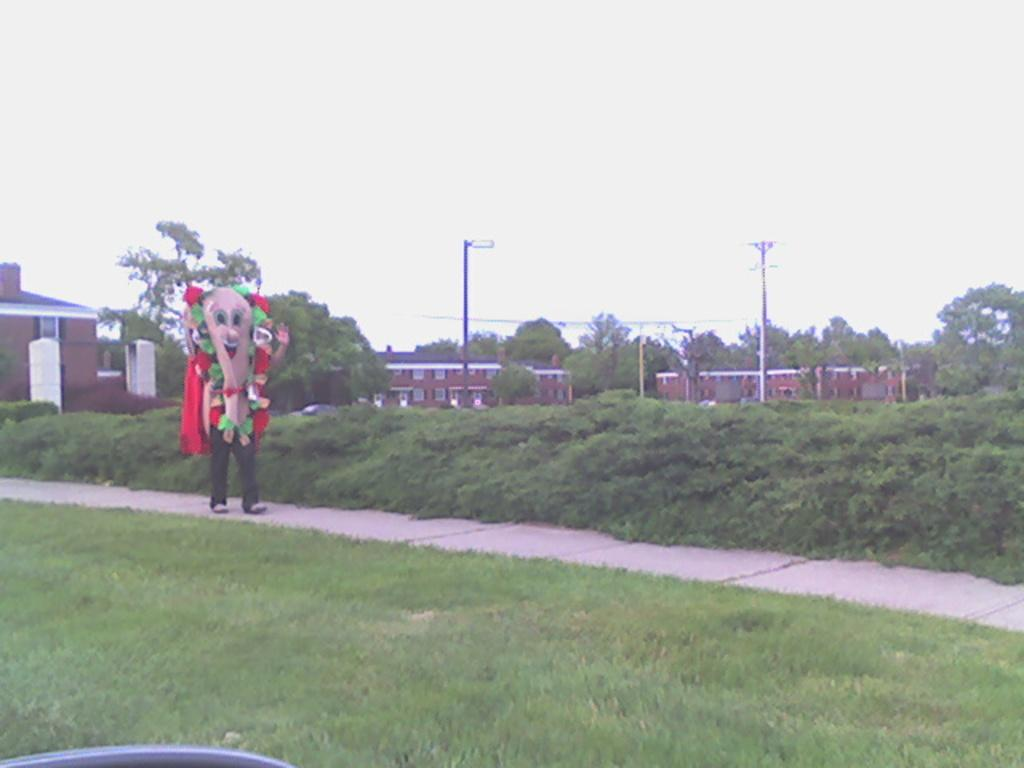What is the person in the image wearing on their face? The person in the image is wearing a mask. What type of natural environment is visible in the image? There is grass, plants, trees, and the sky visible in the image. What structures can be seen in the background of the image? There are poles and houses in the background of the image. Who is the owner of the railway in the image? There is no railway present in the image, so it is not possible to determine the owner. 